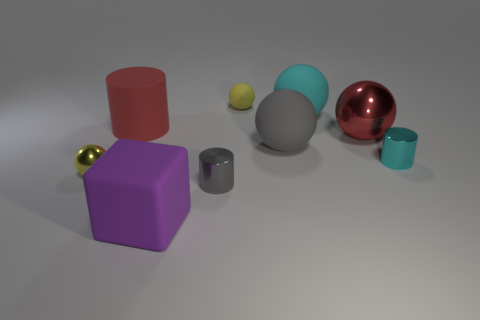What is the object that is to the left of the big purple matte cube and on the right side of the tiny metallic ball made of?
Offer a very short reply. Rubber. What number of other large things have the same shape as the purple thing?
Your answer should be compact. 0. How big is the yellow thing that is behind the tiny cylinder right of the small yellow rubber sphere?
Make the answer very short. Small. Is the color of the big object that is in front of the tiny metal ball the same as the tiny ball that is in front of the red sphere?
Offer a very short reply. No. There is a small cylinder in front of the small metallic cylinder to the right of the big gray matte sphere; what number of tiny yellow spheres are to the left of it?
Offer a very short reply. 1. How many objects are both behind the purple object and in front of the big shiny thing?
Offer a terse response. 4. Is the number of small things that are behind the large metallic thing greater than the number of tiny metal balls?
Ensure brevity in your answer.  No. How many purple matte cubes have the same size as the red shiny object?
Give a very brief answer. 1. There is a metallic thing that is the same color as the matte cylinder; what size is it?
Your answer should be compact. Large. What number of big things are metal objects or yellow rubber spheres?
Your answer should be very brief. 1. 